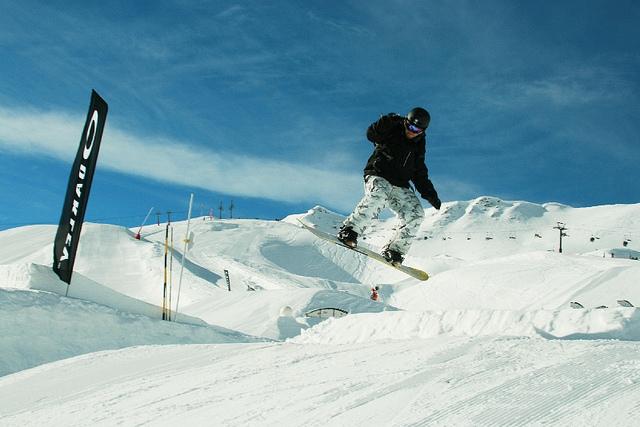What sport is the person playing?
Quick response, please. Snowboarding. Is he wearing camouflage pants?
Keep it brief. Yes. What color is the snow?
Keep it brief. White. 